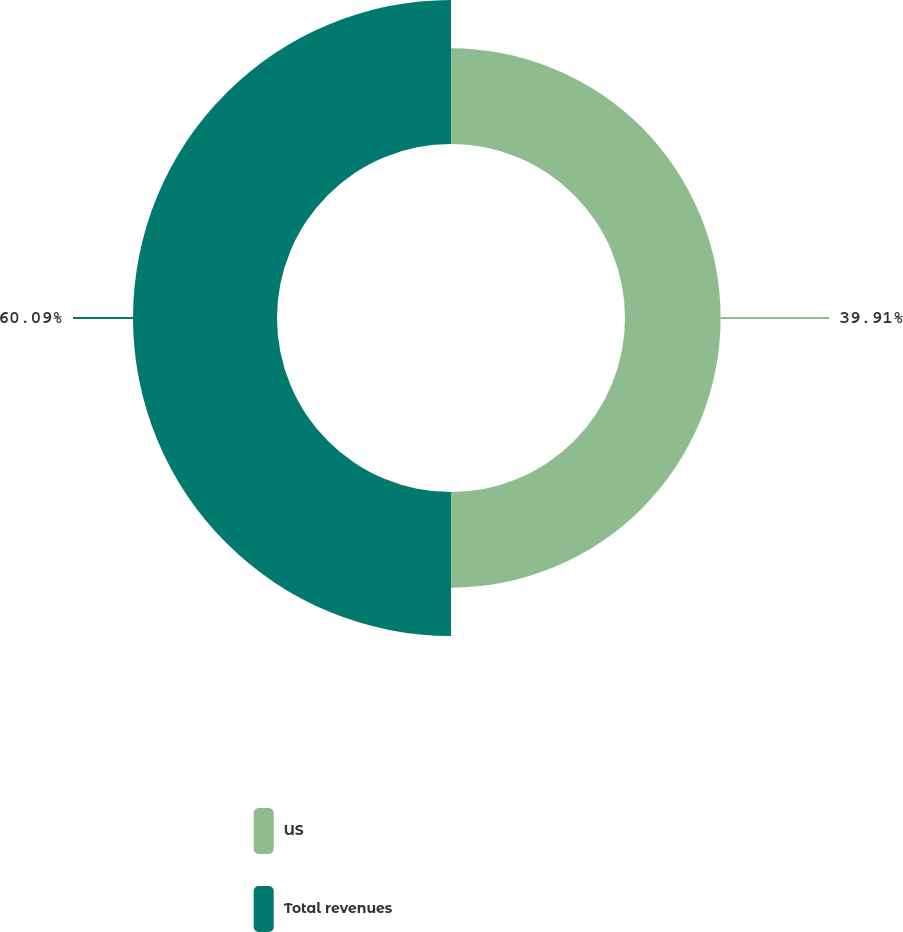Convert chart. <chart><loc_0><loc_0><loc_500><loc_500><pie_chart><fcel>US<fcel>Total revenues<nl><fcel>39.91%<fcel>60.09%<nl></chart> 